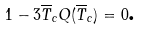Convert formula to latex. <formula><loc_0><loc_0><loc_500><loc_500>1 - 3 \overline { T } _ { c } Q ( \overline { T } _ { c } ) = 0 \text {.}</formula> 